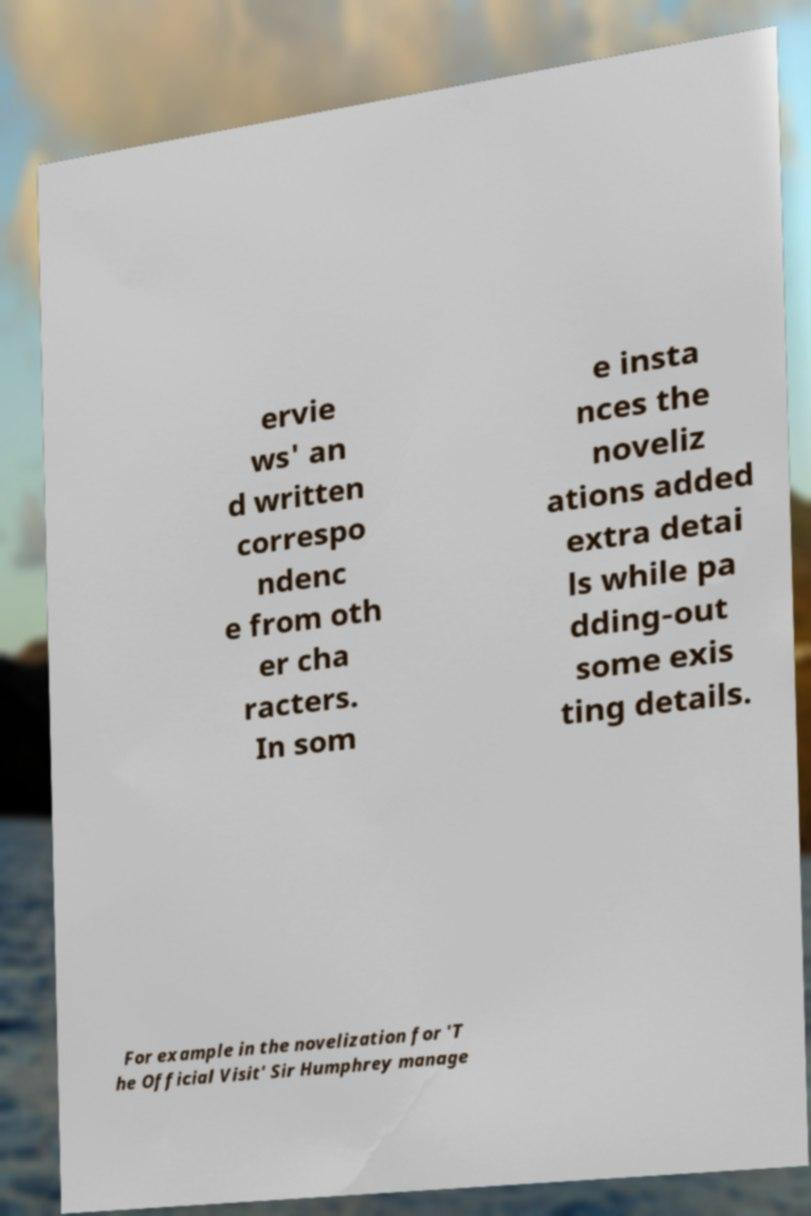For documentation purposes, I need the text within this image transcribed. Could you provide that? ervie ws' an d written correspo ndenc e from oth er cha racters. In som e insta nces the noveliz ations added extra detai ls while pa dding-out some exis ting details. For example in the novelization for 'T he Official Visit' Sir Humphrey manage 